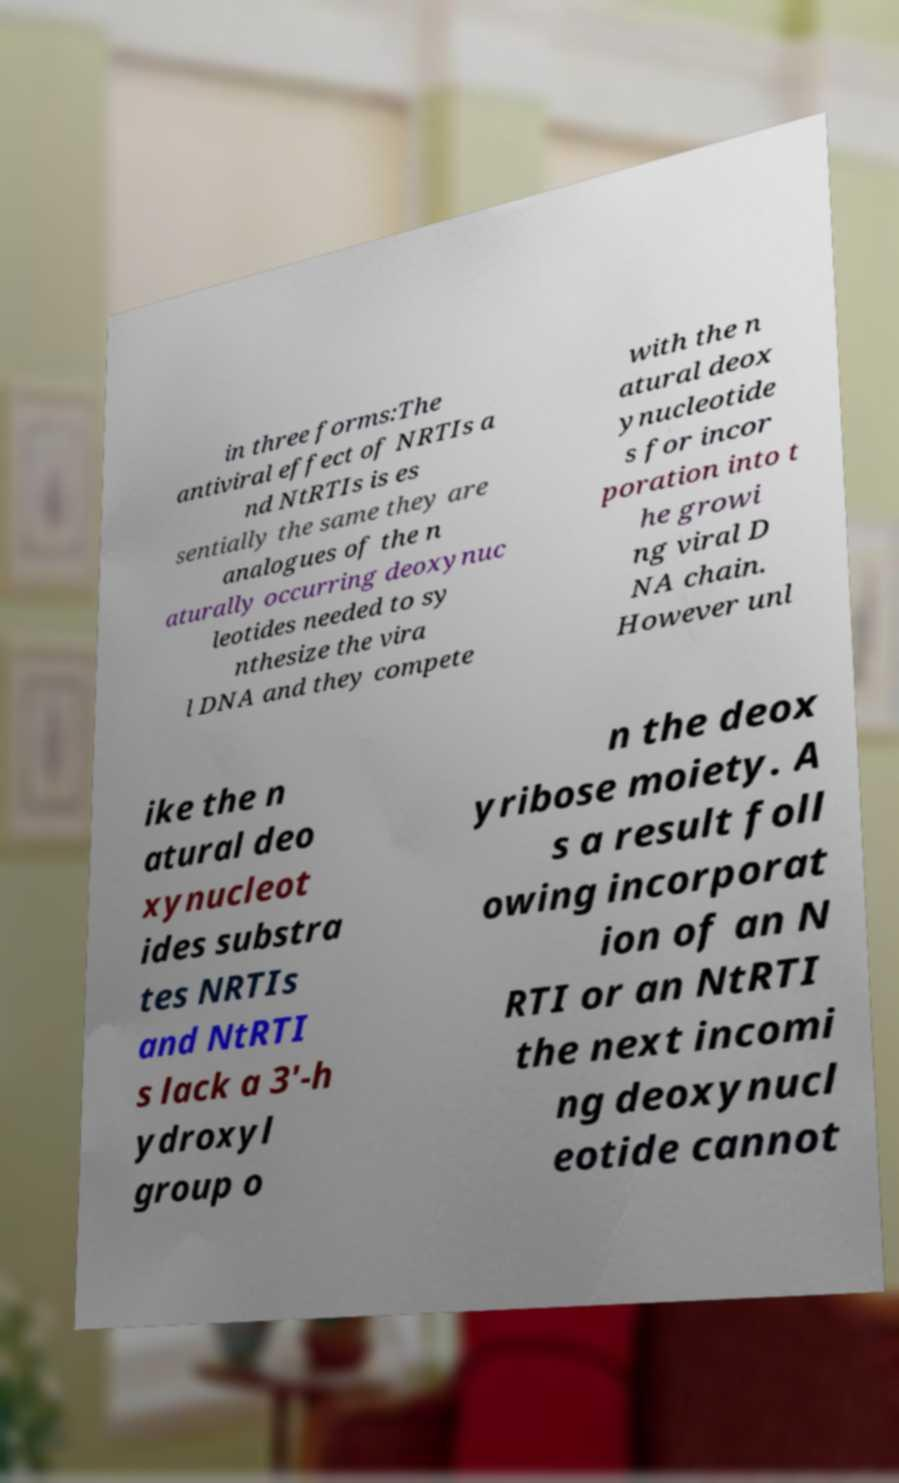For documentation purposes, I need the text within this image transcribed. Could you provide that? in three forms:The antiviral effect of NRTIs a nd NtRTIs is es sentially the same they are analogues of the n aturally occurring deoxynuc leotides needed to sy nthesize the vira l DNA and they compete with the n atural deox ynucleotide s for incor poration into t he growi ng viral D NA chain. However unl ike the n atural deo xynucleot ides substra tes NRTIs and NtRTI s lack a 3′-h ydroxyl group o n the deox yribose moiety. A s a result foll owing incorporat ion of an N RTI or an NtRTI the next incomi ng deoxynucl eotide cannot 